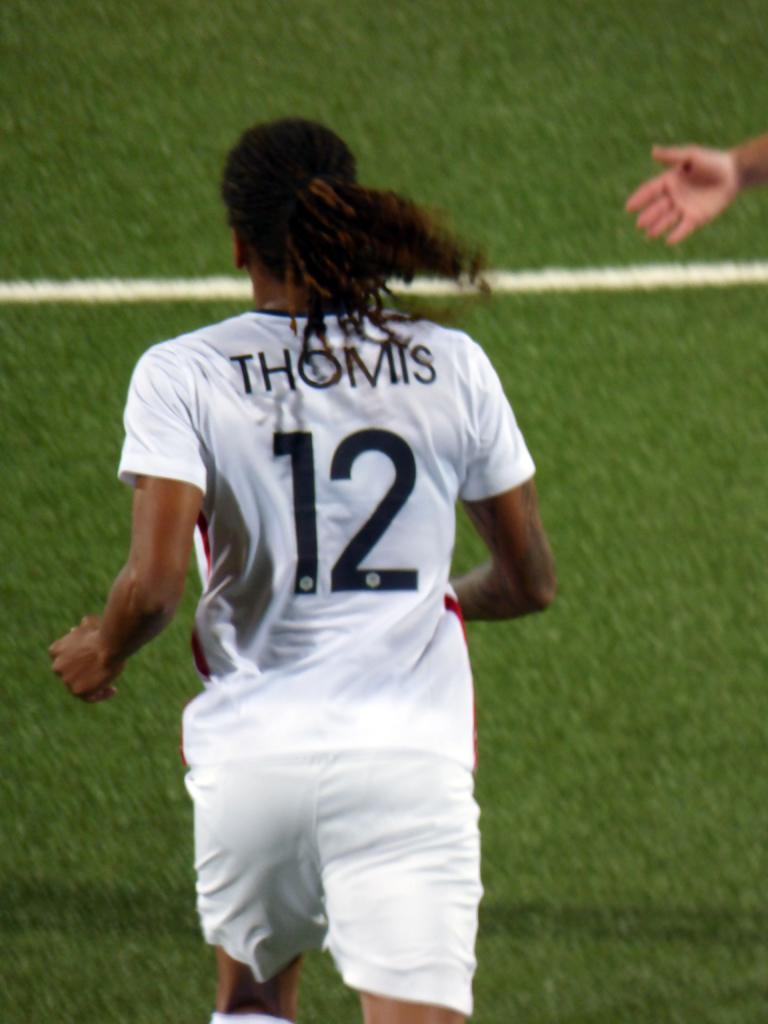What number is on the jersey?
Your answer should be very brief. 12. 